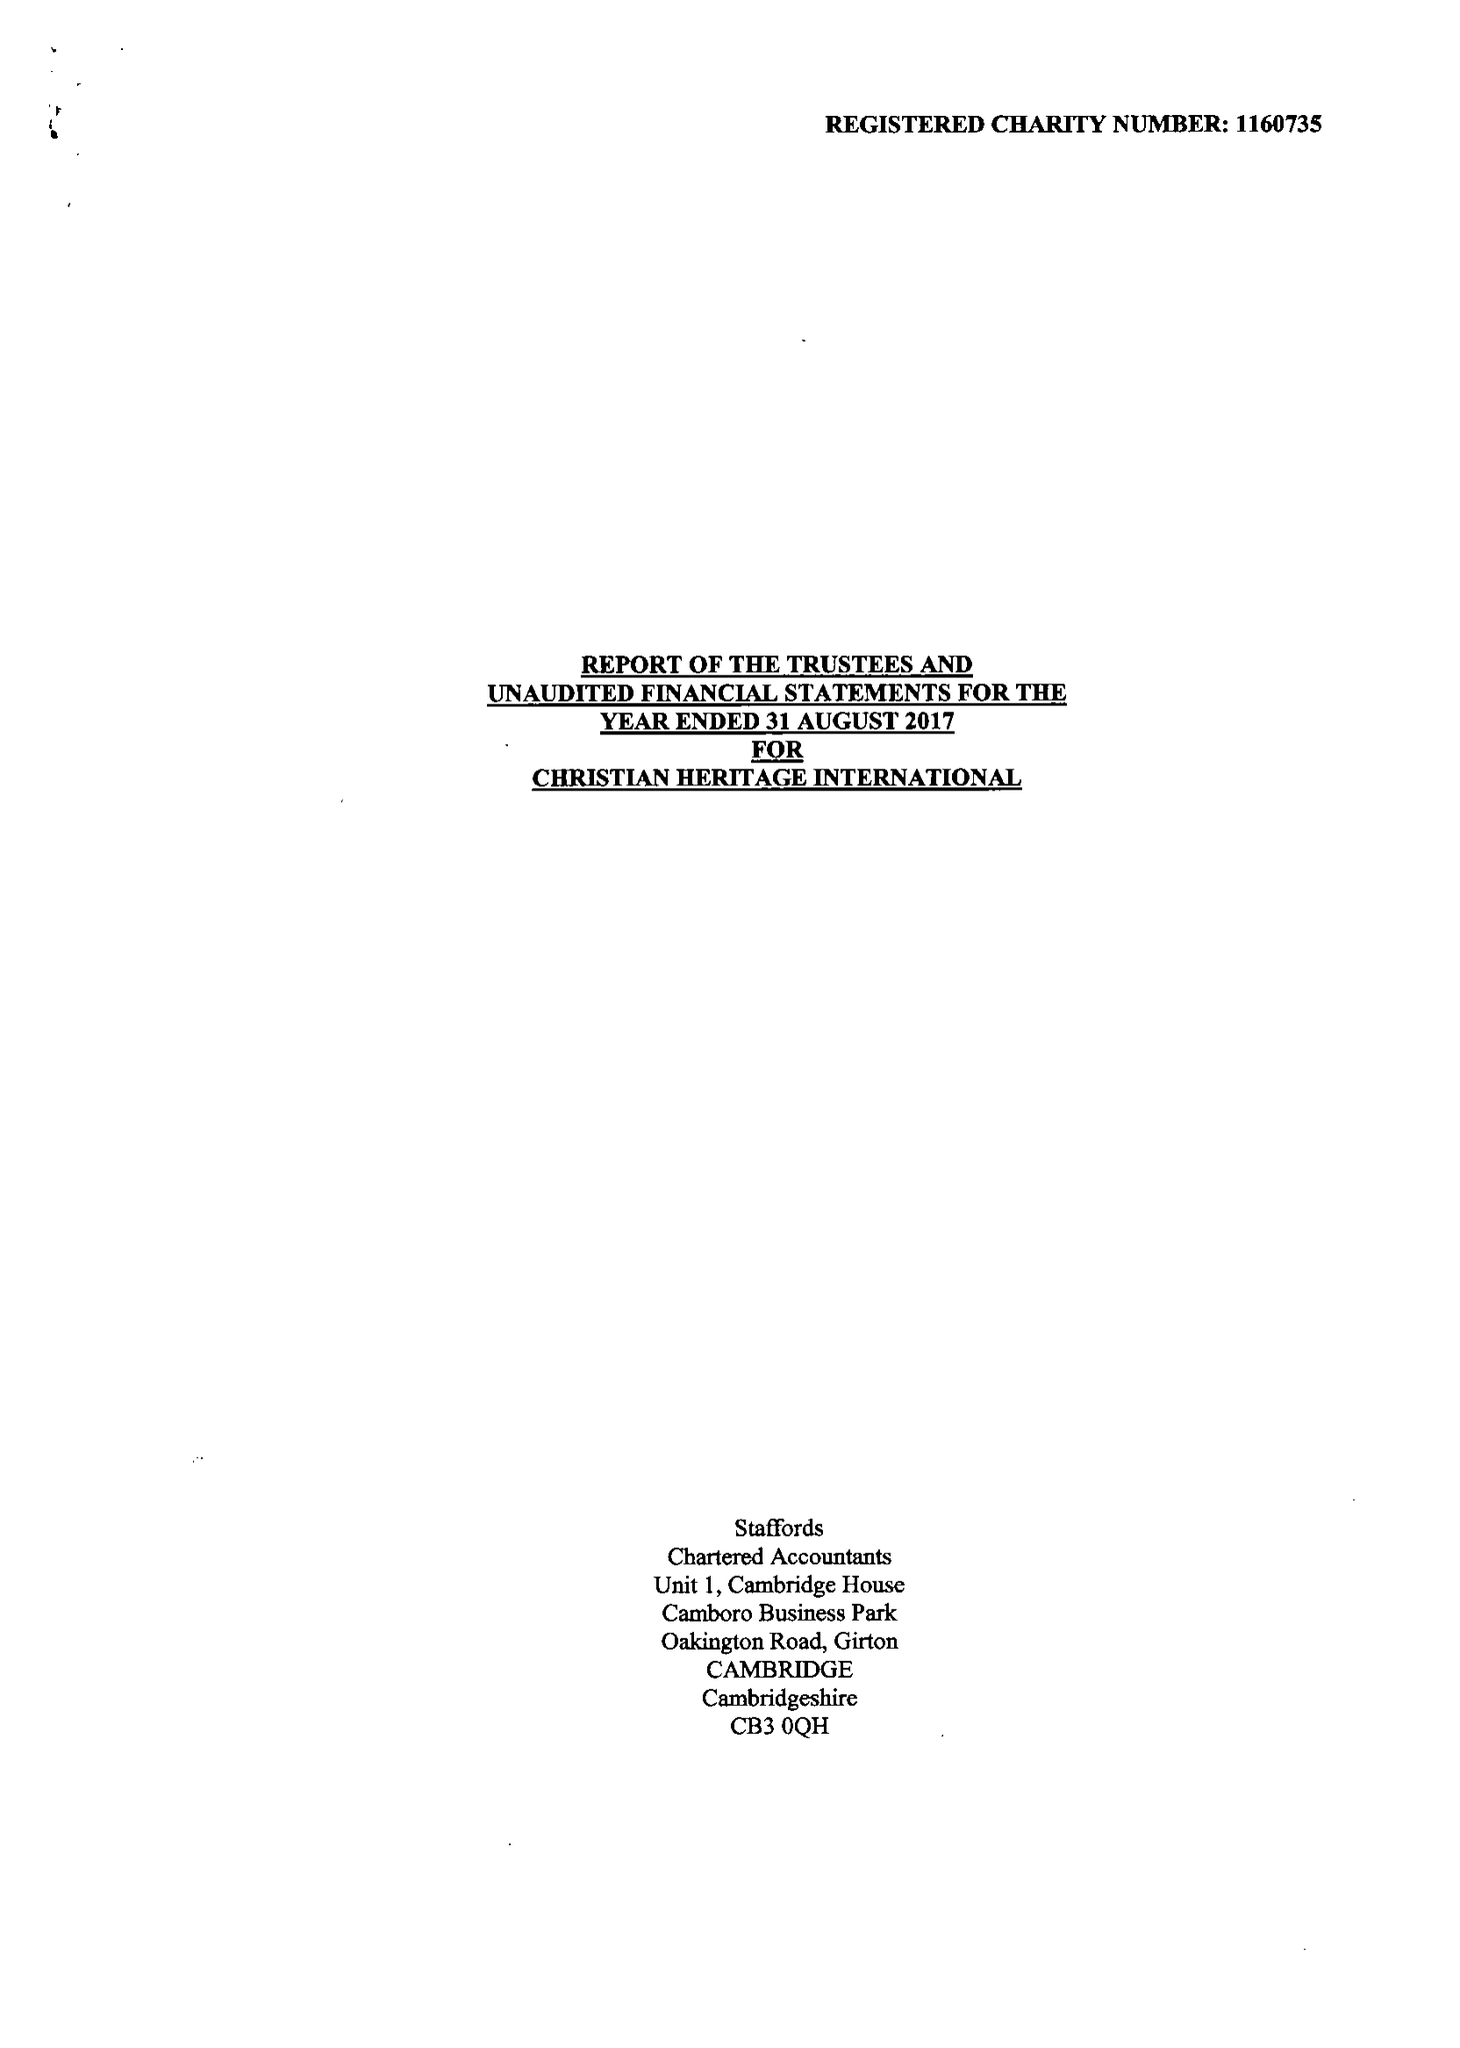What is the value for the address__street_line?
Answer the question using a single word or phrase. 46 THE GLEN 